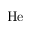Convert formula to latex. <formula><loc_0><loc_0><loc_500><loc_500>H e</formula> 